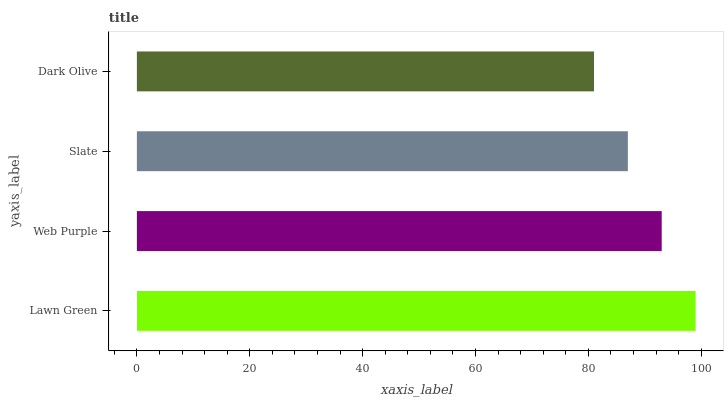Is Dark Olive the minimum?
Answer yes or no. Yes. Is Lawn Green the maximum?
Answer yes or no. Yes. Is Web Purple the minimum?
Answer yes or no. No. Is Web Purple the maximum?
Answer yes or no. No. Is Lawn Green greater than Web Purple?
Answer yes or no. Yes. Is Web Purple less than Lawn Green?
Answer yes or no. Yes. Is Web Purple greater than Lawn Green?
Answer yes or no. No. Is Lawn Green less than Web Purple?
Answer yes or no. No. Is Web Purple the high median?
Answer yes or no. Yes. Is Slate the low median?
Answer yes or no. Yes. Is Dark Olive the high median?
Answer yes or no. No. Is Dark Olive the low median?
Answer yes or no. No. 